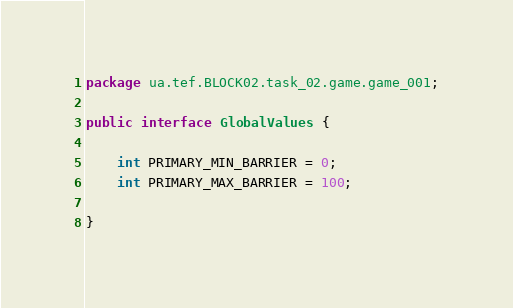<code> <loc_0><loc_0><loc_500><loc_500><_Java_>package ua.tef.BLOCK02.task_02.game.game_001;

public interface GlobalValues {

    int PRIMARY_MIN_BARRIER = 0;
    int PRIMARY_MAX_BARRIER = 100;

}</code> 